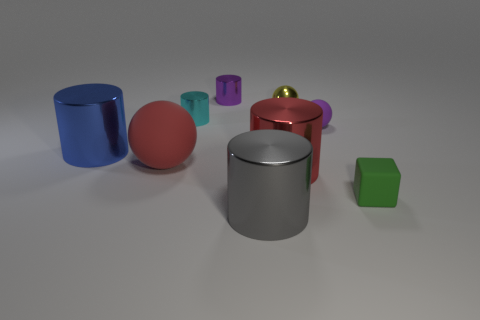Do the large cylinder left of the red matte sphere and the cyan thing have the same material?
Offer a terse response. Yes. What number of other objects are there of the same material as the tiny cube?
Provide a short and direct response. 2. What number of objects are big cylinders in front of the blue metallic cylinder or large things that are to the left of the gray metallic cylinder?
Ensure brevity in your answer.  4. There is a tiny cyan metallic object left of the purple ball; is its shape the same as the large object to the left of the big rubber object?
Your response must be concise. Yes. There is a cyan thing that is the same size as the yellow sphere; what shape is it?
Keep it short and to the point. Cylinder. What number of matte things are tiny cubes or gray things?
Offer a terse response. 1. Do the purple object that is behind the cyan cylinder and the big cylinder in front of the green rubber cube have the same material?
Provide a short and direct response. Yes. The ball that is made of the same material as the big red cylinder is what color?
Your answer should be compact. Yellow. Are there more small purple metallic cylinders behind the purple metal cylinder than tiny shiny spheres to the left of the gray metallic cylinder?
Provide a succinct answer. No. Are any small purple blocks visible?
Offer a very short reply. No. 